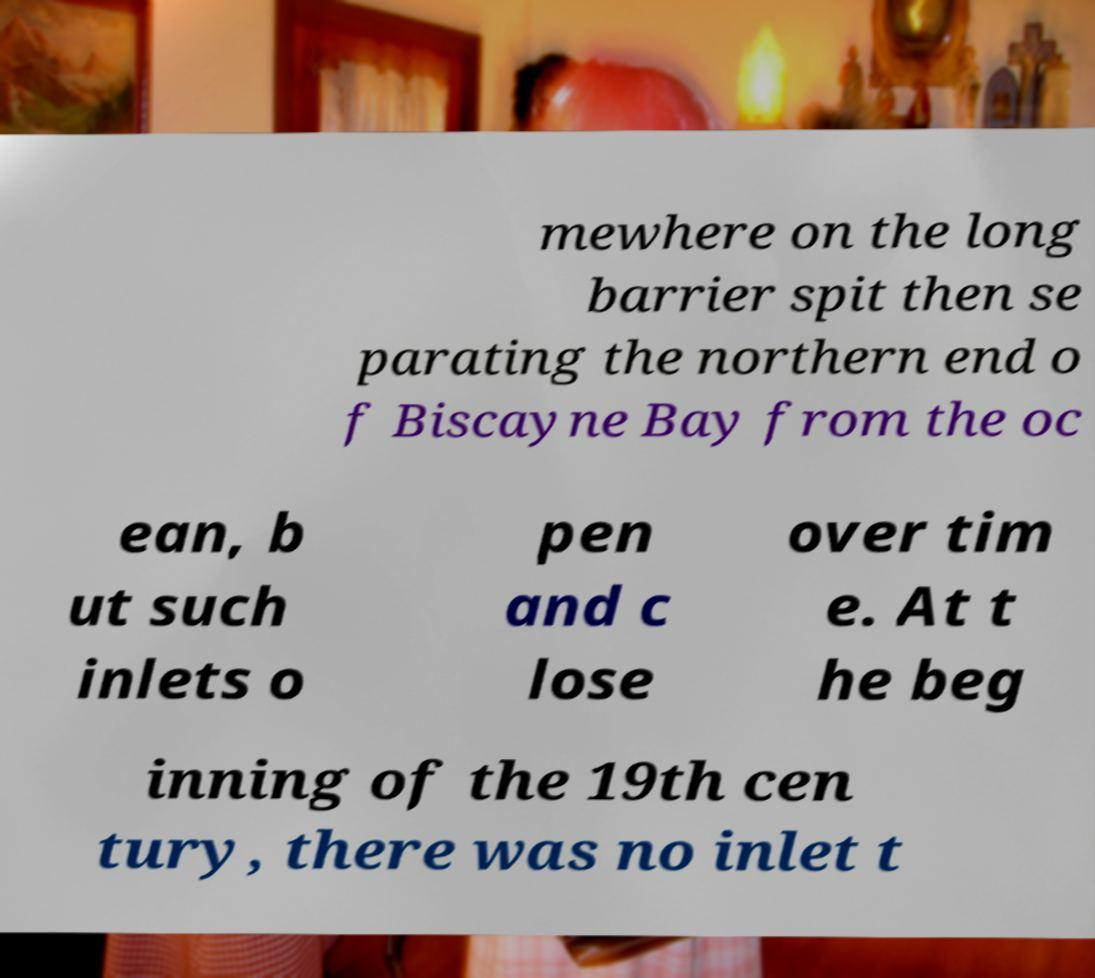Could you extract and type out the text from this image? mewhere on the long barrier spit then se parating the northern end o f Biscayne Bay from the oc ean, b ut such inlets o pen and c lose over tim e. At t he beg inning of the 19th cen tury, there was no inlet t 